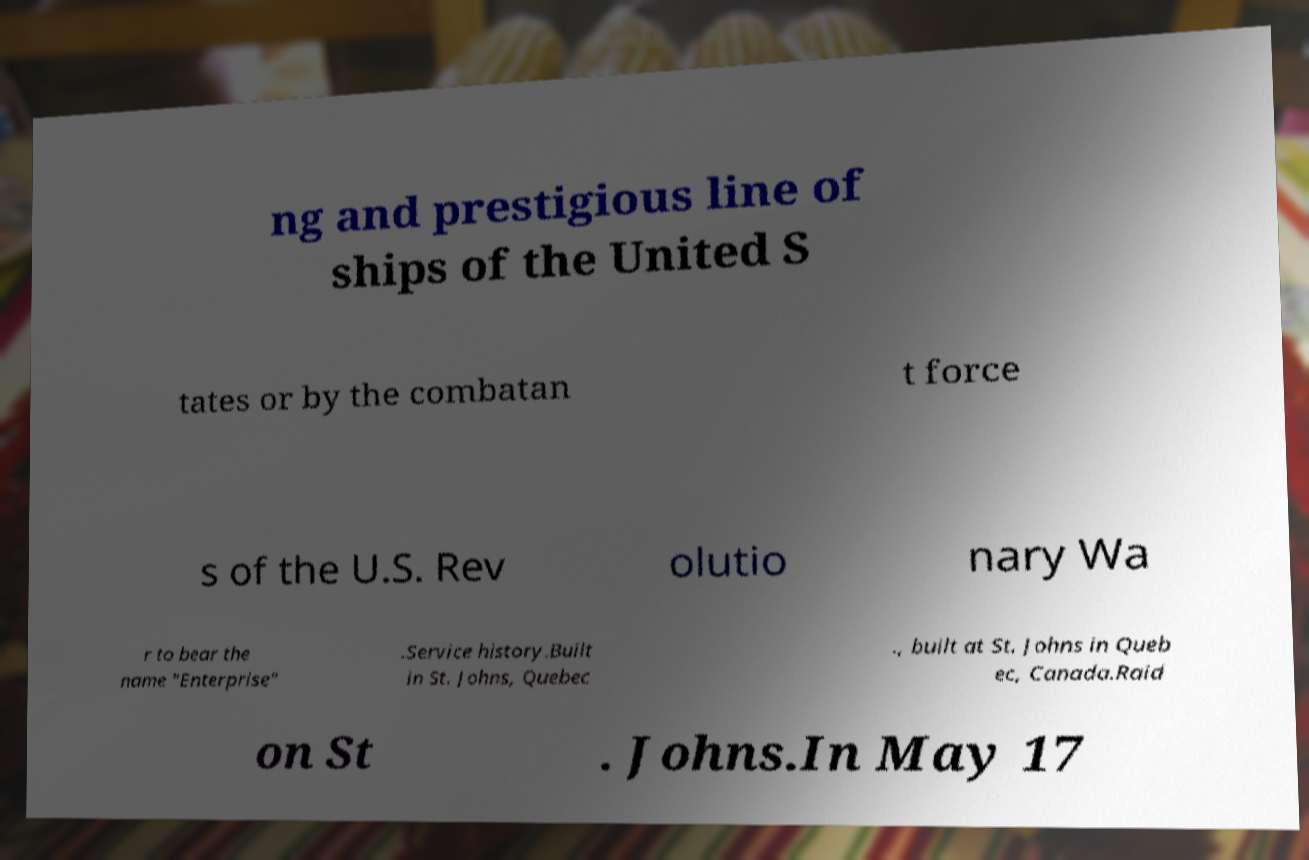What messages or text are displayed in this image? I need them in a readable, typed format. ng and prestigious line of ships of the United S tates or by the combatan t force s of the U.S. Rev olutio nary Wa r to bear the name "Enterprise" .Service history.Built in St. Johns, Quebec ., built at St. Johns in Queb ec, Canada.Raid on St . Johns.In May 17 